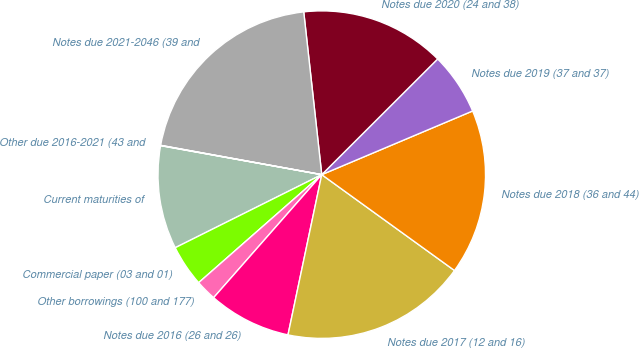Convert chart. <chart><loc_0><loc_0><loc_500><loc_500><pie_chart><fcel>Current maturities of<fcel>Commercial paper (03 and 01)<fcel>Other borrowings (100 and 177)<fcel>Notes due 2016 (26 and 26)<fcel>Notes due 2017 (12 and 16)<fcel>Notes due 2018 (36 and 44)<fcel>Notes due 2019 (37 and 37)<fcel>Notes due 2020 (24 and 38)<fcel>Notes due 2021-2046 (39 and<fcel>Other due 2016-2021 (43 and<nl><fcel>10.2%<fcel>4.1%<fcel>2.06%<fcel>8.17%<fcel>18.35%<fcel>16.31%<fcel>6.13%<fcel>14.27%<fcel>20.38%<fcel>0.03%<nl></chart> 